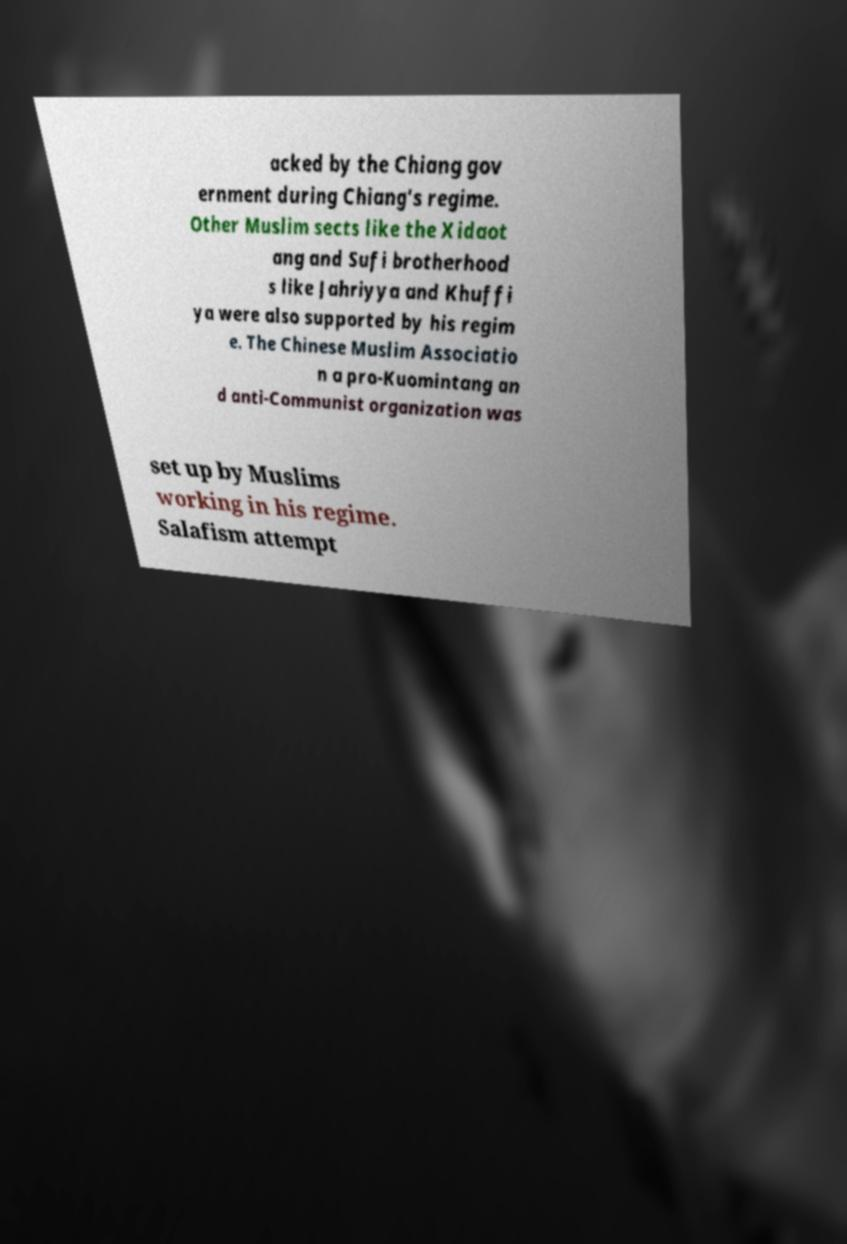Please identify and transcribe the text found in this image. acked by the Chiang gov ernment during Chiang's regime. Other Muslim sects like the Xidaot ang and Sufi brotherhood s like Jahriyya and Khuffi ya were also supported by his regim e. The Chinese Muslim Associatio n a pro-Kuomintang an d anti-Communist organization was set up by Muslims working in his regime. Salafism attempt 